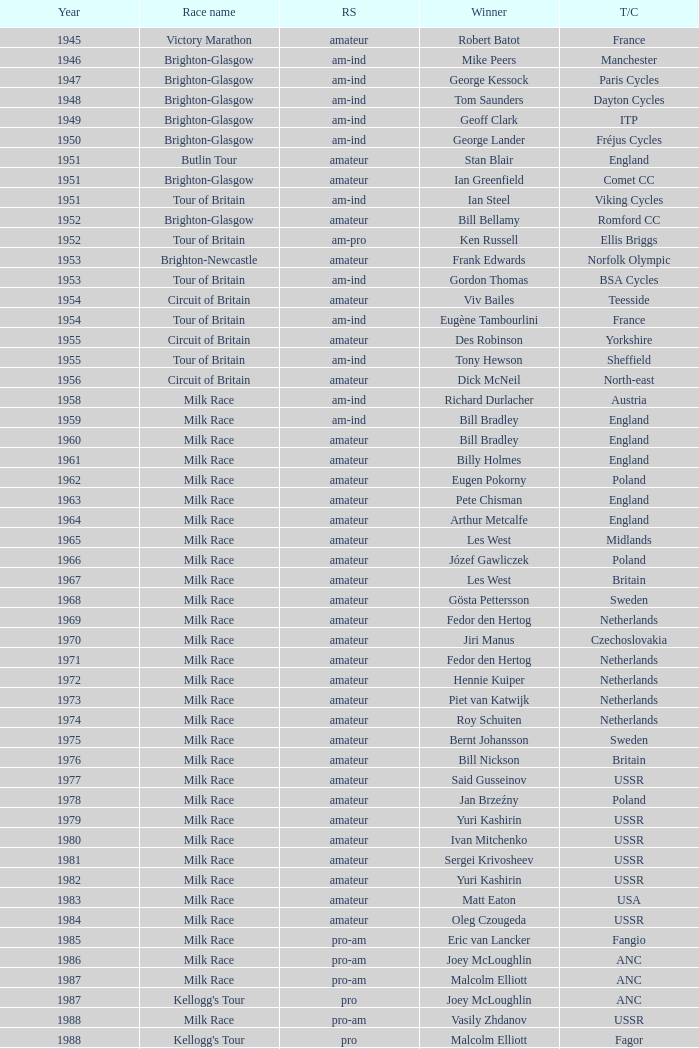Who was the winner in 1973 with an amateur rider status? Piet van Katwijk. 